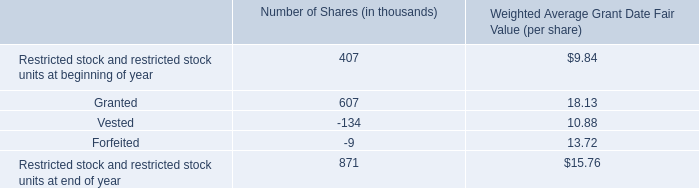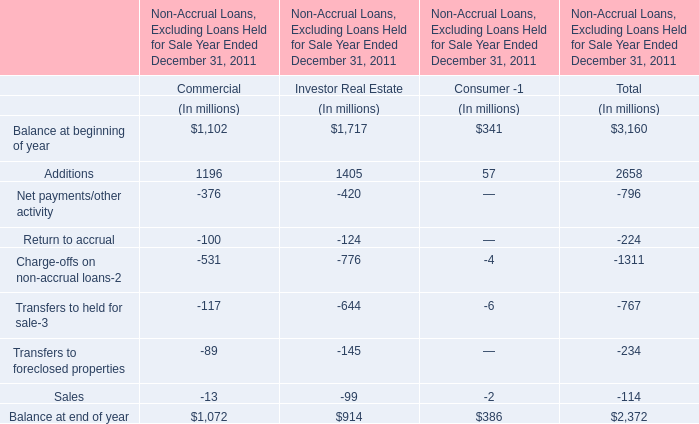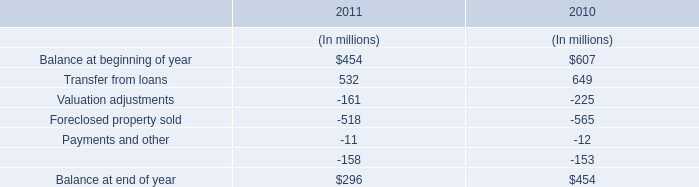Which element makes up more than 20 % of the total for Commercial in 2011? 
Answer: Balance at beginning of year,Additions. 